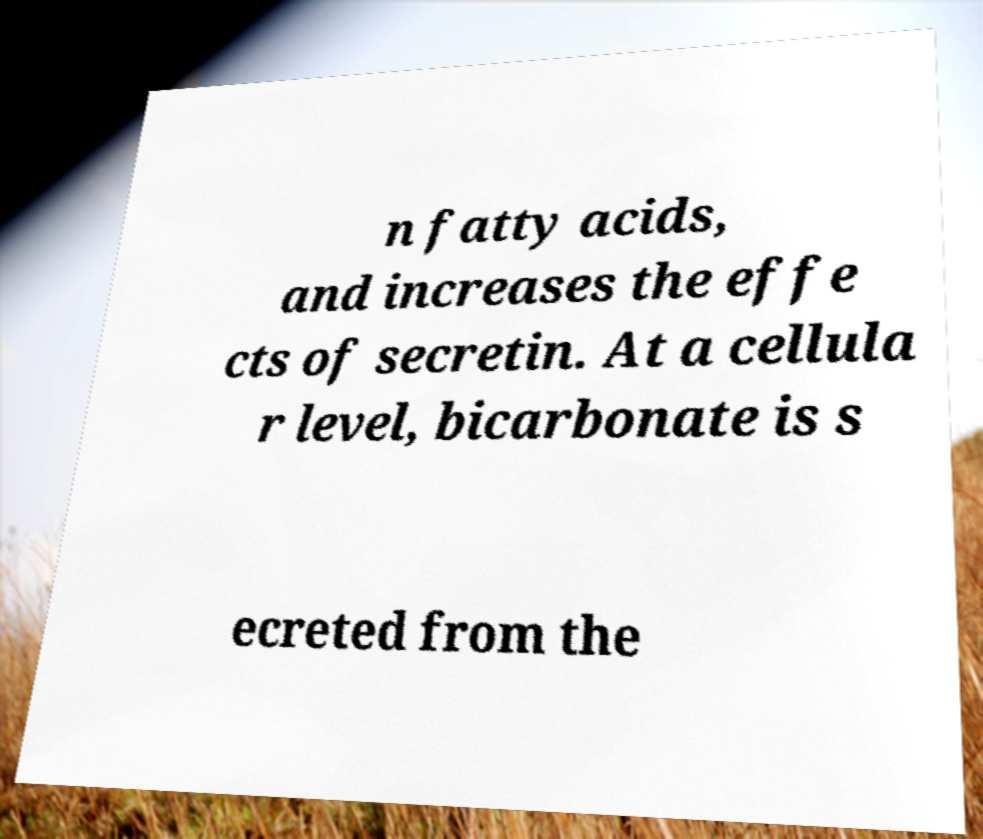Please identify and transcribe the text found in this image. n fatty acids, and increases the effe cts of secretin. At a cellula r level, bicarbonate is s ecreted from the 